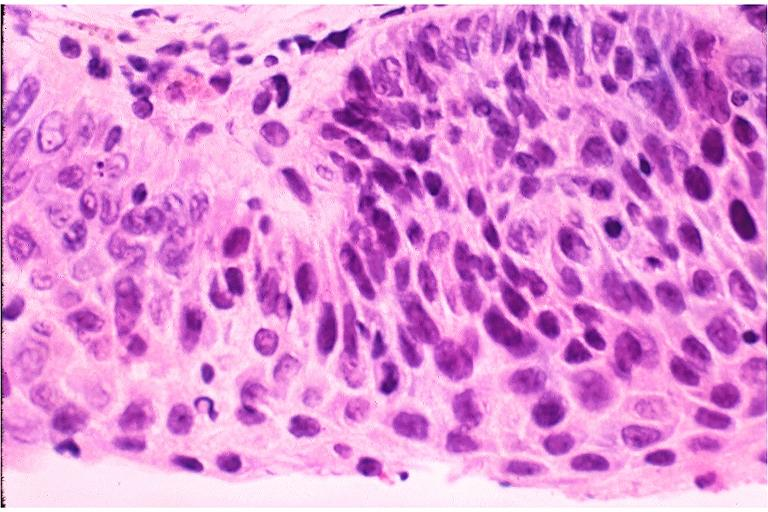what is present?
Answer the question using a single word or phrase. Oral 